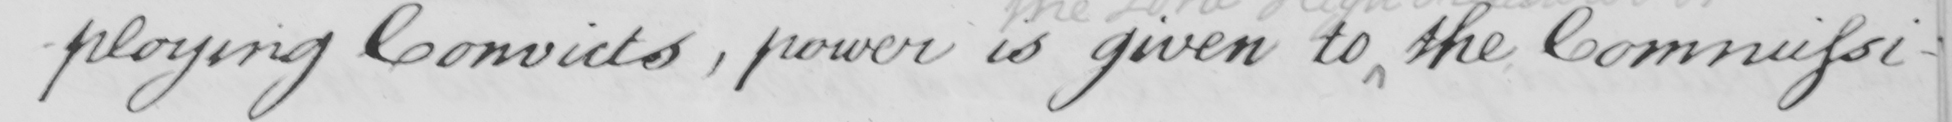What is written in this line of handwriting? -ploying Convicts , power is given to the Commissi- 